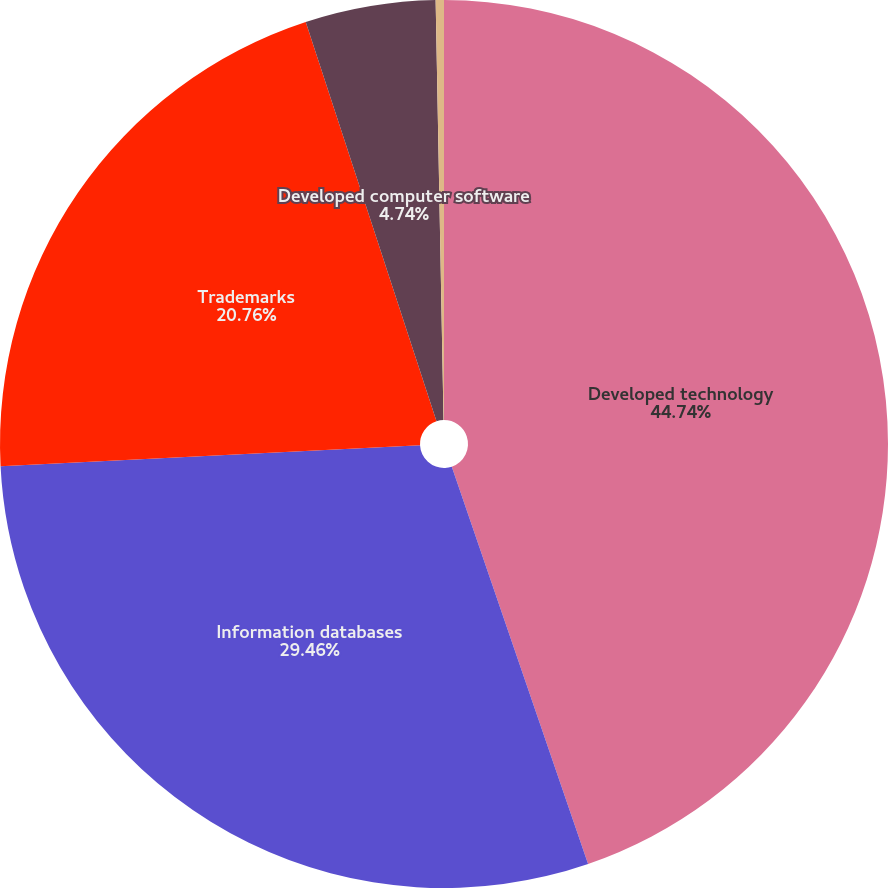Convert chart to OTSL. <chart><loc_0><loc_0><loc_500><loc_500><pie_chart><fcel>Developed technology<fcel>Information databases<fcel>Trademarks<fcel>Developed computer software<fcel>Other<nl><fcel>44.74%<fcel>29.46%<fcel>20.76%<fcel>4.74%<fcel>0.3%<nl></chart> 